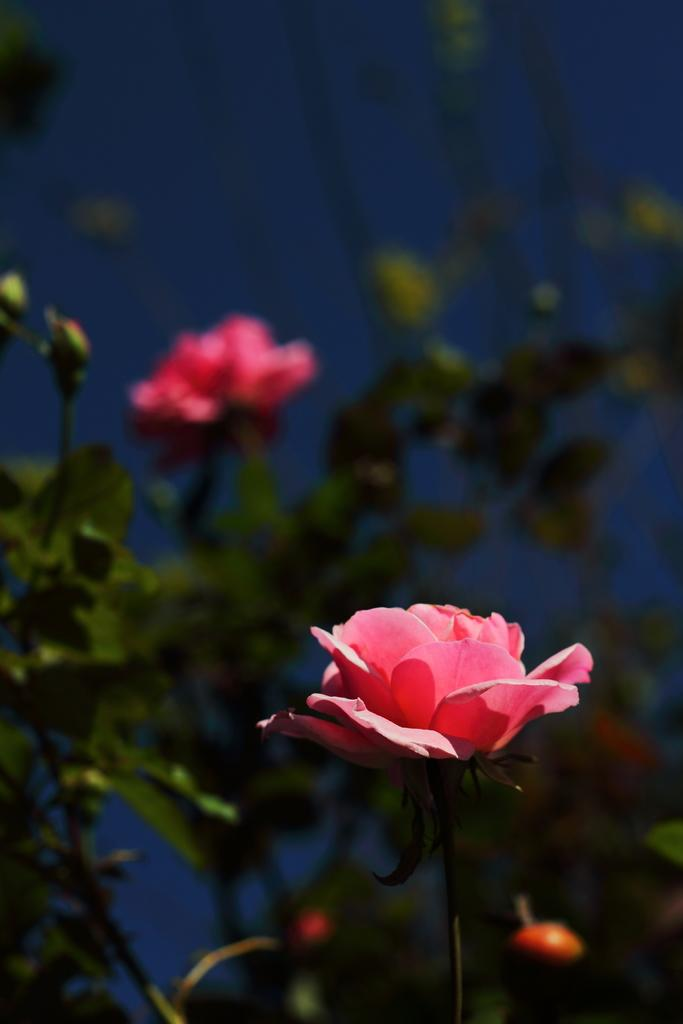What is the main subject in the middle of the image? There are flowers in the middle of the image. What else can be seen in the image besides the flowers? There are plants behind the flowers. What time does the lock open in the image? There is no lock present in the image, so it is not possible to determine when it opens. 